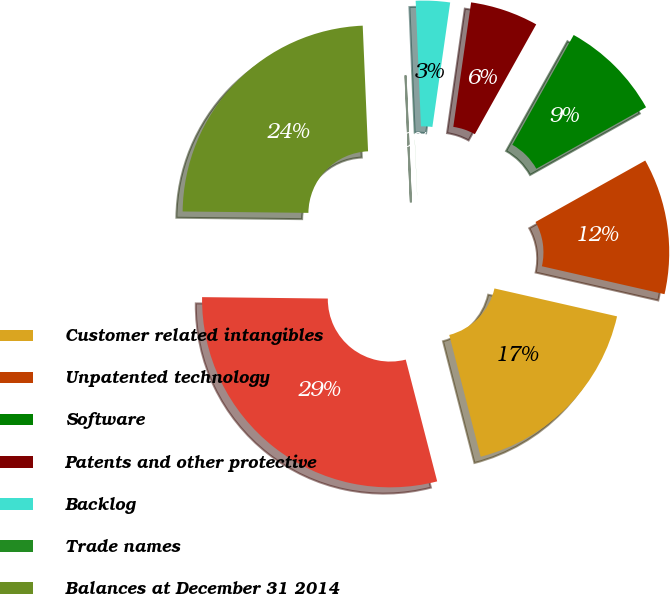Convert chart to OTSL. <chart><loc_0><loc_0><loc_500><loc_500><pie_chart><fcel>Customer related intangibles<fcel>Unpatented technology<fcel>Software<fcel>Patents and other protective<fcel>Backlog<fcel>Trade names<fcel>Balances at December 31 2014<fcel>Balances at December 31 2015<nl><fcel>17.42%<fcel>11.69%<fcel>8.77%<fcel>5.85%<fcel>2.93%<fcel>0.01%<fcel>24.15%<fcel>29.21%<nl></chart> 